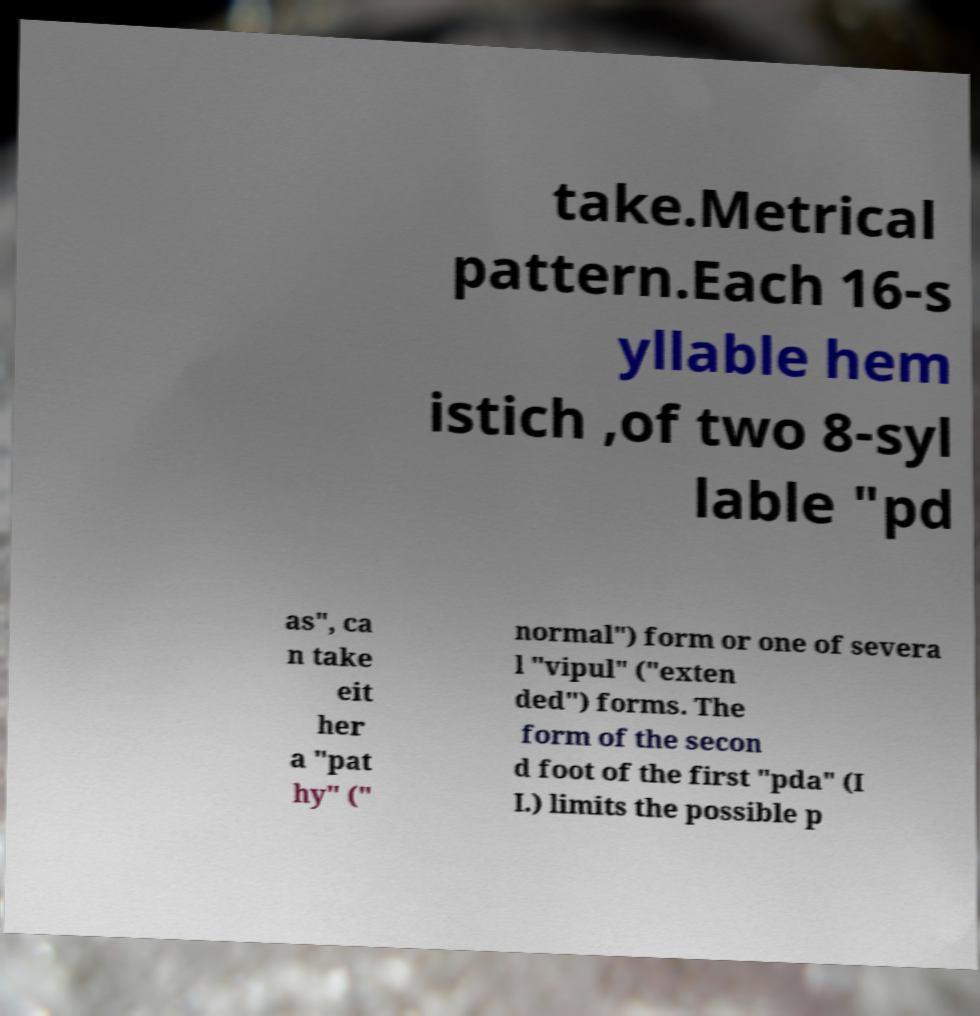For documentation purposes, I need the text within this image transcribed. Could you provide that? take.Metrical pattern.Each 16-s yllable hem istich ,of two 8-syl lable "pd as", ca n take eit her a "pat hy" (" normal") form or one of severa l "vipul" ("exten ded") forms. The form of the secon d foot of the first "pda" (I I.) limits the possible p 